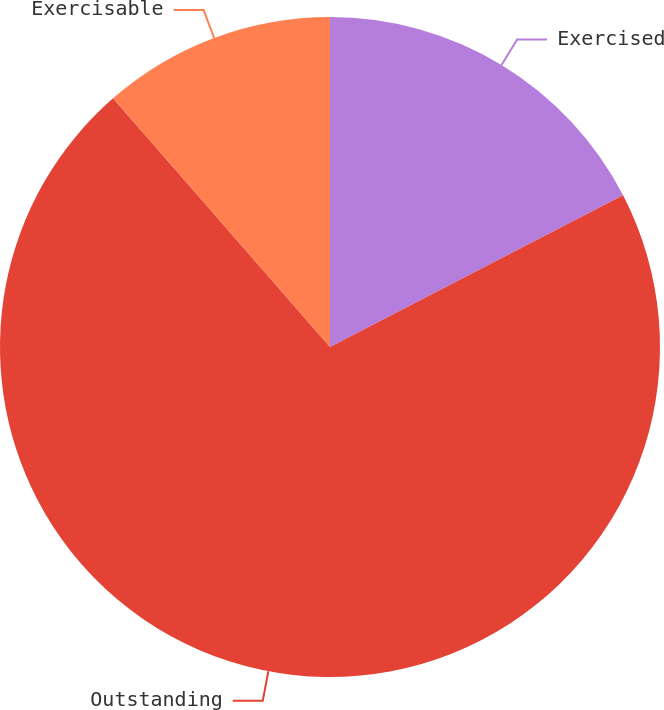Convert chart to OTSL. <chart><loc_0><loc_0><loc_500><loc_500><pie_chart><fcel>Exercised<fcel>Outstanding<fcel>Exercisable<nl><fcel>17.4%<fcel>71.18%<fcel>11.42%<nl></chart> 